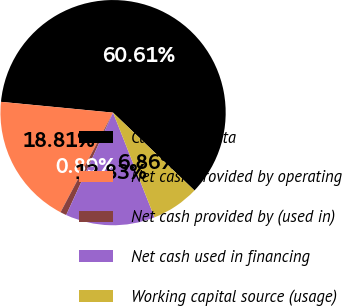<chart> <loc_0><loc_0><loc_500><loc_500><pie_chart><fcel>Cash Flow Data<fcel>Net cash provided by operating<fcel>Net cash provided by (used in)<fcel>Net cash used in financing<fcel>Working capital source (usage)<nl><fcel>60.62%<fcel>18.81%<fcel>0.89%<fcel>12.83%<fcel>6.86%<nl></chart> 